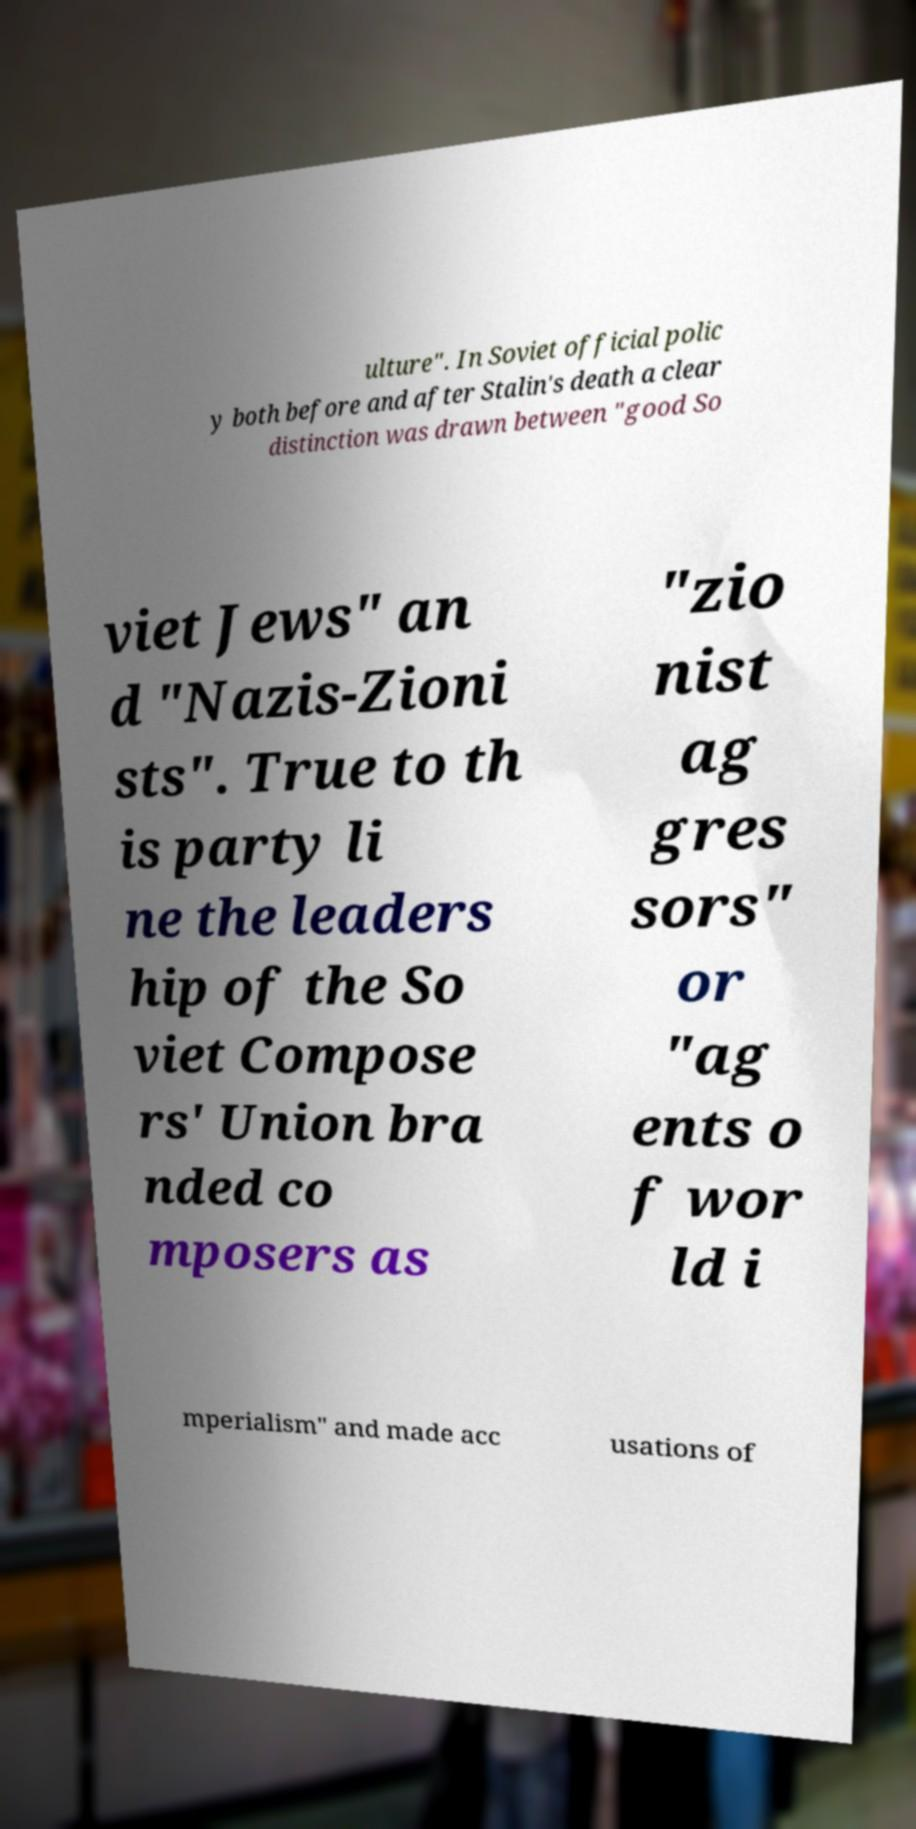Can you read and provide the text displayed in the image?This photo seems to have some interesting text. Can you extract and type it out for me? ulture". In Soviet official polic y both before and after Stalin's death a clear distinction was drawn between "good So viet Jews" an d "Nazis-Zioni sts". True to th is party li ne the leaders hip of the So viet Compose rs' Union bra nded co mposers as "zio nist ag gres sors" or "ag ents o f wor ld i mperialism" and made acc usations of 